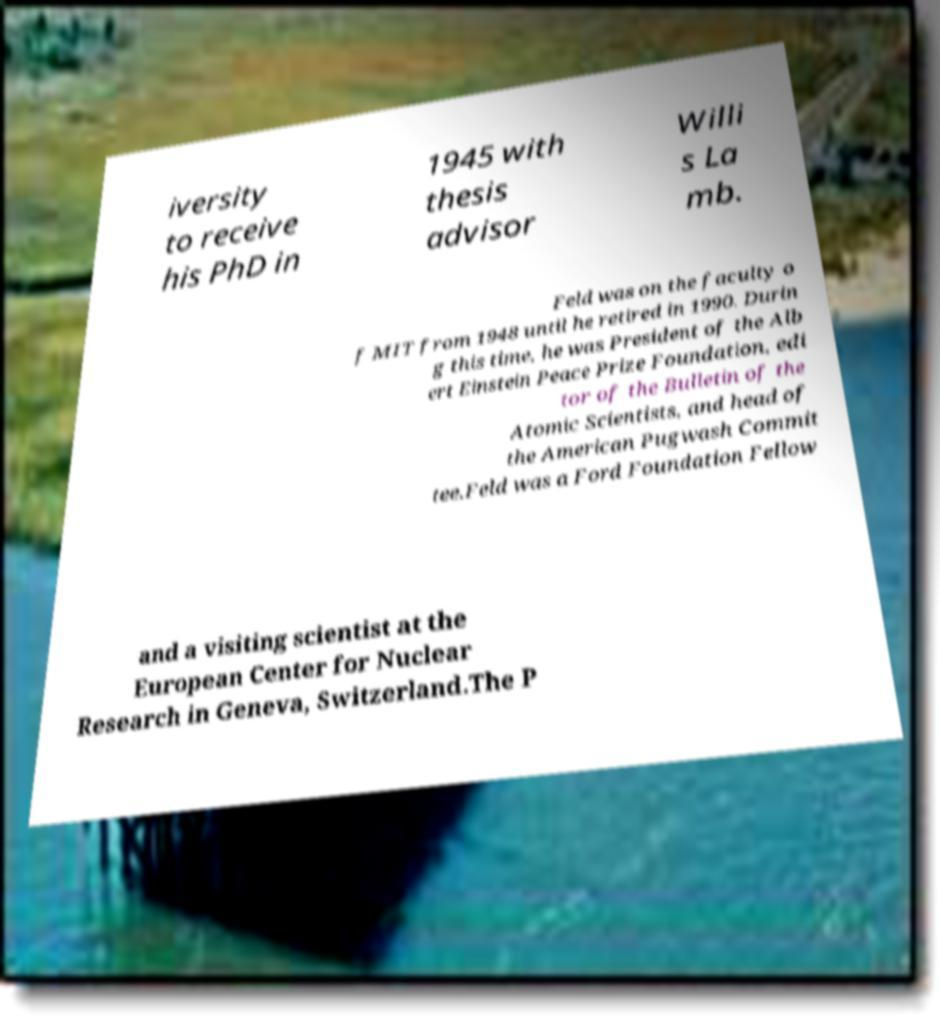Can you accurately transcribe the text from the provided image for me? iversity to receive his PhD in 1945 with thesis advisor Willi s La mb. Feld was on the faculty o f MIT from 1948 until he retired in 1990. Durin g this time, he was President of the Alb ert Einstein Peace Prize Foundation, edi tor of the Bulletin of the Atomic Scientists, and head of the American Pugwash Commit tee.Feld was a Ford Foundation Fellow and a visiting scientist at the European Center for Nuclear Research in Geneva, Switzerland.The P 